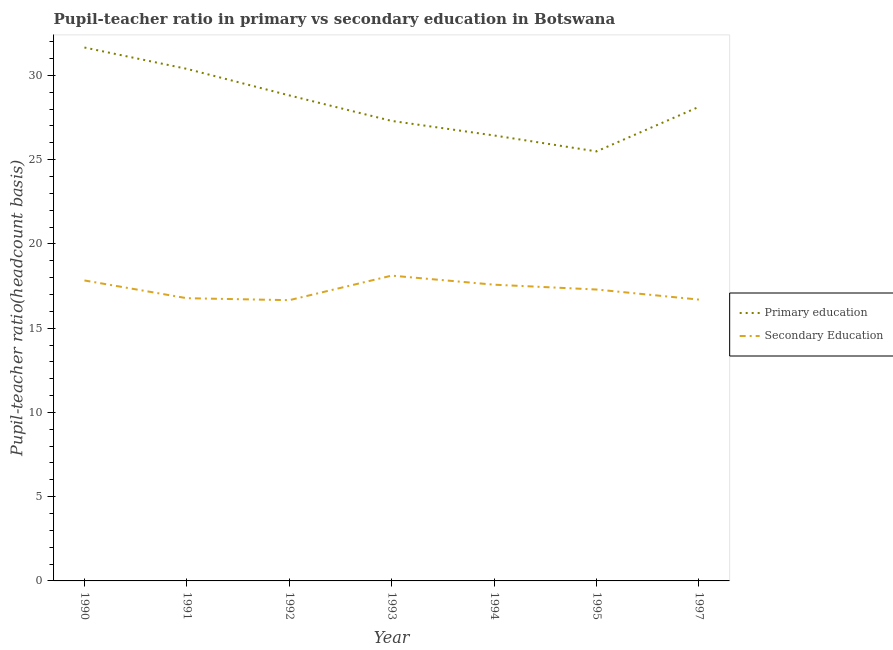Does the line corresponding to pupil-teacher ratio in primary education intersect with the line corresponding to pupil teacher ratio on secondary education?
Provide a short and direct response. No. What is the pupil teacher ratio on secondary education in 1995?
Provide a succinct answer. 17.29. Across all years, what is the maximum pupil-teacher ratio in primary education?
Make the answer very short. 31.66. Across all years, what is the minimum pupil-teacher ratio in primary education?
Your answer should be very brief. 25.49. In which year was the pupil-teacher ratio in primary education maximum?
Provide a short and direct response. 1990. In which year was the pupil teacher ratio on secondary education minimum?
Offer a terse response. 1992. What is the total pupil-teacher ratio in primary education in the graph?
Provide a succinct answer. 198.22. What is the difference between the pupil-teacher ratio in primary education in 1991 and that in 1993?
Give a very brief answer. 3.09. What is the difference between the pupil teacher ratio on secondary education in 1995 and the pupil-teacher ratio in primary education in 1993?
Provide a short and direct response. -10.01. What is the average pupil-teacher ratio in primary education per year?
Your answer should be very brief. 28.32. In the year 1995, what is the difference between the pupil teacher ratio on secondary education and pupil-teacher ratio in primary education?
Give a very brief answer. -8.2. In how many years, is the pupil-teacher ratio in primary education greater than 26?
Keep it short and to the point. 6. What is the ratio of the pupil teacher ratio on secondary education in 1992 to that in 1993?
Your answer should be very brief. 0.92. Is the pupil-teacher ratio in primary education in 1994 less than that in 1997?
Offer a very short reply. Yes. What is the difference between the highest and the second highest pupil teacher ratio on secondary education?
Your answer should be very brief. 0.29. What is the difference between the highest and the lowest pupil-teacher ratio in primary education?
Provide a succinct answer. 6.17. Is the sum of the pupil-teacher ratio in primary education in 1990 and 1995 greater than the maximum pupil teacher ratio on secondary education across all years?
Make the answer very short. Yes. How many lines are there?
Your answer should be very brief. 2. Does the graph contain any zero values?
Your answer should be compact. No. How many legend labels are there?
Your response must be concise. 2. How are the legend labels stacked?
Your response must be concise. Vertical. What is the title of the graph?
Your answer should be very brief. Pupil-teacher ratio in primary vs secondary education in Botswana. Does "Non-solid fuel" appear as one of the legend labels in the graph?
Give a very brief answer. No. What is the label or title of the X-axis?
Make the answer very short. Year. What is the label or title of the Y-axis?
Provide a short and direct response. Pupil-teacher ratio(headcount basis). What is the Pupil-teacher ratio(headcount basis) of Primary education in 1990?
Provide a succinct answer. 31.66. What is the Pupil-teacher ratio(headcount basis) in Secondary Education in 1990?
Provide a succinct answer. 17.83. What is the Pupil-teacher ratio(headcount basis) in Primary education in 1991?
Make the answer very short. 30.39. What is the Pupil-teacher ratio(headcount basis) of Secondary Education in 1991?
Your answer should be very brief. 16.78. What is the Pupil-teacher ratio(headcount basis) in Primary education in 1992?
Make the answer very short. 28.81. What is the Pupil-teacher ratio(headcount basis) in Secondary Education in 1992?
Give a very brief answer. 16.66. What is the Pupil-teacher ratio(headcount basis) in Primary education in 1993?
Your answer should be very brief. 27.3. What is the Pupil-teacher ratio(headcount basis) of Secondary Education in 1993?
Provide a short and direct response. 18.12. What is the Pupil-teacher ratio(headcount basis) in Primary education in 1994?
Ensure brevity in your answer.  26.44. What is the Pupil-teacher ratio(headcount basis) of Secondary Education in 1994?
Give a very brief answer. 17.58. What is the Pupil-teacher ratio(headcount basis) in Primary education in 1995?
Make the answer very short. 25.49. What is the Pupil-teacher ratio(headcount basis) in Secondary Education in 1995?
Your answer should be compact. 17.29. What is the Pupil-teacher ratio(headcount basis) in Primary education in 1997?
Offer a terse response. 28.14. What is the Pupil-teacher ratio(headcount basis) in Secondary Education in 1997?
Provide a short and direct response. 16.7. Across all years, what is the maximum Pupil-teacher ratio(headcount basis) in Primary education?
Your response must be concise. 31.66. Across all years, what is the maximum Pupil-teacher ratio(headcount basis) in Secondary Education?
Give a very brief answer. 18.12. Across all years, what is the minimum Pupil-teacher ratio(headcount basis) in Primary education?
Offer a terse response. 25.49. Across all years, what is the minimum Pupil-teacher ratio(headcount basis) of Secondary Education?
Give a very brief answer. 16.66. What is the total Pupil-teacher ratio(headcount basis) in Primary education in the graph?
Offer a terse response. 198.22. What is the total Pupil-teacher ratio(headcount basis) in Secondary Education in the graph?
Ensure brevity in your answer.  120.96. What is the difference between the Pupil-teacher ratio(headcount basis) in Primary education in 1990 and that in 1991?
Offer a terse response. 1.27. What is the difference between the Pupil-teacher ratio(headcount basis) in Secondary Education in 1990 and that in 1991?
Provide a succinct answer. 1.05. What is the difference between the Pupil-teacher ratio(headcount basis) of Primary education in 1990 and that in 1992?
Ensure brevity in your answer.  2.84. What is the difference between the Pupil-teacher ratio(headcount basis) of Secondary Education in 1990 and that in 1992?
Provide a succinct answer. 1.17. What is the difference between the Pupil-teacher ratio(headcount basis) in Primary education in 1990 and that in 1993?
Offer a very short reply. 4.36. What is the difference between the Pupil-teacher ratio(headcount basis) of Secondary Education in 1990 and that in 1993?
Offer a terse response. -0.29. What is the difference between the Pupil-teacher ratio(headcount basis) in Primary education in 1990 and that in 1994?
Make the answer very short. 5.22. What is the difference between the Pupil-teacher ratio(headcount basis) in Secondary Education in 1990 and that in 1994?
Ensure brevity in your answer.  0.25. What is the difference between the Pupil-teacher ratio(headcount basis) in Primary education in 1990 and that in 1995?
Ensure brevity in your answer.  6.17. What is the difference between the Pupil-teacher ratio(headcount basis) of Secondary Education in 1990 and that in 1995?
Ensure brevity in your answer.  0.54. What is the difference between the Pupil-teacher ratio(headcount basis) of Primary education in 1990 and that in 1997?
Give a very brief answer. 3.52. What is the difference between the Pupil-teacher ratio(headcount basis) in Secondary Education in 1990 and that in 1997?
Provide a short and direct response. 1.14. What is the difference between the Pupil-teacher ratio(headcount basis) of Primary education in 1991 and that in 1992?
Offer a terse response. 1.57. What is the difference between the Pupil-teacher ratio(headcount basis) of Secondary Education in 1991 and that in 1992?
Ensure brevity in your answer.  0.12. What is the difference between the Pupil-teacher ratio(headcount basis) of Primary education in 1991 and that in 1993?
Your response must be concise. 3.09. What is the difference between the Pupil-teacher ratio(headcount basis) of Secondary Education in 1991 and that in 1993?
Give a very brief answer. -1.34. What is the difference between the Pupil-teacher ratio(headcount basis) of Primary education in 1991 and that in 1994?
Ensure brevity in your answer.  3.95. What is the difference between the Pupil-teacher ratio(headcount basis) in Secondary Education in 1991 and that in 1994?
Give a very brief answer. -0.8. What is the difference between the Pupil-teacher ratio(headcount basis) of Primary education in 1991 and that in 1995?
Keep it short and to the point. 4.9. What is the difference between the Pupil-teacher ratio(headcount basis) of Secondary Education in 1991 and that in 1995?
Offer a very short reply. -0.52. What is the difference between the Pupil-teacher ratio(headcount basis) of Primary education in 1991 and that in 1997?
Your answer should be compact. 2.25. What is the difference between the Pupil-teacher ratio(headcount basis) of Secondary Education in 1991 and that in 1997?
Make the answer very short. 0.08. What is the difference between the Pupil-teacher ratio(headcount basis) of Primary education in 1992 and that in 1993?
Make the answer very short. 1.51. What is the difference between the Pupil-teacher ratio(headcount basis) in Secondary Education in 1992 and that in 1993?
Your answer should be compact. -1.46. What is the difference between the Pupil-teacher ratio(headcount basis) of Primary education in 1992 and that in 1994?
Your response must be concise. 2.38. What is the difference between the Pupil-teacher ratio(headcount basis) in Secondary Education in 1992 and that in 1994?
Keep it short and to the point. -0.92. What is the difference between the Pupil-teacher ratio(headcount basis) in Primary education in 1992 and that in 1995?
Your response must be concise. 3.32. What is the difference between the Pupil-teacher ratio(headcount basis) in Secondary Education in 1992 and that in 1995?
Offer a very short reply. -0.63. What is the difference between the Pupil-teacher ratio(headcount basis) of Primary education in 1992 and that in 1997?
Ensure brevity in your answer.  0.68. What is the difference between the Pupil-teacher ratio(headcount basis) in Secondary Education in 1992 and that in 1997?
Your answer should be very brief. -0.03. What is the difference between the Pupil-teacher ratio(headcount basis) of Primary education in 1993 and that in 1994?
Your answer should be very brief. 0.86. What is the difference between the Pupil-teacher ratio(headcount basis) in Secondary Education in 1993 and that in 1994?
Provide a succinct answer. 0.54. What is the difference between the Pupil-teacher ratio(headcount basis) of Primary education in 1993 and that in 1995?
Your response must be concise. 1.81. What is the difference between the Pupil-teacher ratio(headcount basis) of Secondary Education in 1993 and that in 1995?
Give a very brief answer. 0.82. What is the difference between the Pupil-teacher ratio(headcount basis) of Primary education in 1993 and that in 1997?
Your answer should be compact. -0.84. What is the difference between the Pupil-teacher ratio(headcount basis) of Secondary Education in 1993 and that in 1997?
Keep it short and to the point. 1.42. What is the difference between the Pupil-teacher ratio(headcount basis) in Primary education in 1994 and that in 1995?
Offer a very short reply. 0.95. What is the difference between the Pupil-teacher ratio(headcount basis) in Secondary Education in 1994 and that in 1995?
Keep it short and to the point. 0.29. What is the difference between the Pupil-teacher ratio(headcount basis) in Primary education in 1994 and that in 1997?
Provide a succinct answer. -1.7. What is the difference between the Pupil-teacher ratio(headcount basis) in Secondary Education in 1994 and that in 1997?
Your response must be concise. 0.88. What is the difference between the Pupil-teacher ratio(headcount basis) in Primary education in 1995 and that in 1997?
Give a very brief answer. -2.64. What is the difference between the Pupil-teacher ratio(headcount basis) of Secondary Education in 1995 and that in 1997?
Ensure brevity in your answer.  0.6. What is the difference between the Pupil-teacher ratio(headcount basis) of Primary education in 1990 and the Pupil-teacher ratio(headcount basis) of Secondary Education in 1991?
Keep it short and to the point. 14.88. What is the difference between the Pupil-teacher ratio(headcount basis) in Primary education in 1990 and the Pupil-teacher ratio(headcount basis) in Secondary Education in 1992?
Make the answer very short. 14.99. What is the difference between the Pupil-teacher ratio(headcount basis) of Primary education in 1990 and the Pupil-teacher ratio(headcount basis) of Secondary Education in 1993?
Make the answer very short. 13.54. What is the difference between the Pupil-teacher ratio(headcount basis) in Primary education in 1990 and the Pupil-teacher ratio(headcount basis) in Secondary Education in 1994?
Your answer should be very brief. 14.08. What is the difference between the Pupil-teacher ratio(headcount basis) of Primary education in 1990 and the Pupil-teacher ratio(headcount basis) of Secondary Education in 1995?
Offer a terse response. 14.36. What is the difference between the Pupil-teacher ratio(headcount basis) of Primary education in 1990 and the Pupil-teacher ratio(headcount basis) of Secondary Education in 1997?
Ensure brevity in your answer.  14.96. What is the difference between the Pupil-teacher ratio(headcount basis) in Primary education in 1991 and the Pupil-teacher ratio(headcount basis) in Secondary Education in 1992?
Provide a short and direct response. 13.73. What is the difference between the Pupil-teacher ratio(headcount basis) of Primary education in 1991 and the Pupil-teacher ratio(headcount basis) of Secondary Education in 1993?
Offer a very short reply. 12.27. What is the difference between the Pupil-teacher ratio(headcount basis) of Primary education in 1991 and the Pupil-teacher ratio(headcount basis) of Secondary Education in 1994?
Provide a succinct answer. 12.81. What is the difference between the Pupil-teacher ratio(headcount basis) of Primary education in 1991 and the Pupil-teacher ratio(headcount basis) of Secondary Education in 1995?
Ensure brevity in your answer.  13.1. What is the difference between the Pupil-teacher ratio(headcount basis) of Primary education in 1991 and the Pupil-teacher ratio(headcount basis) of Secondary Education in 1997?
Make the answer very short. 13.69. What is the difference between the Pupil-teacher ratio(headcount basis) in Primary education in 1992 and the Pupil-teacher ratio(headcount basis) in Secondary Education in 1993?
Ensure brevity in your answer.  10.7. What is the difference between the Pupil-teacher ratio(headcount basis) of Primary education in 1992 and the Pupil-teacher ratio(headcount basis) of Secondary Education in 1994?
Your answer should be very brief. 11.23. What is the difference between the Pupil-teacher ratio(headcount basis) in Primary education in 1992 and the Pupil-teacher ratio(headcount basis) in Secondary Education in 1995?
Ensure brevity in your answer.  11.52. What is the difference between the Pupil-teacher ratio(headcount basis) of Primary education in 1992 and the Pupil-teacher ratio(headcount basis) of Secondary Education in 1997?
Your answer should be compact. 12.12. What is the difference between the Pupil-teacher ratio(headcount basis) of Primary education in 1993 and the Pupil-teacher ratio(headcount basis) of Secondary Education in 1994?
Offer a terse response. 9.72. What is the difference between the Pupil-teacher ratio(headcount basis) of Primary education in 1993 and the Pupil-teacher ratio(headcount basis) of Secondary Education in 1995?
Your answer should be compact. 10.01. What is the difference between the Pupil-teacher ratio(headcount basis) of Primary education in 1993 and the Pupil-teacher ratio(headcount basis) of Secondary Education in 1997?
Offer a terse response. 10.6. What is the difference between the Pupil-teacher ratio(headcount basis) in Primary education in 1994 and the Pupil-teacher ratio(headcount basis) in Secondary Education in 1995?
Your answer should be compact. 9.14. What is the difference between the Pupil-teacher ratio(headcount basis) of Primary education in 1994 and the Pupil-teacher ratio(headcount basis) of Secondary Education in 1997?
Give a very brief answer. 9.74. What is the difference between the Pupil-teacher ratio(headcount basis) of Primary education in 1995 and the Pupil-teacher ratio(headcount basis) of Secondary Education in 1997?
Make the answer very short. 8.79. What is the average Pupil-teacher ratio(headcount basis) in Primary education per year?
Ensure brevity in your answer.  28.32. What is the average Pupil-teacher ratio(headcount basis) of Secondary Education per year?
Provide a succinct answer. 17.28. In the year 1990, what is the difference between the Pupil-teacher ratio(headcount basis) of Primary education and Pupil-teacher ratio(headcount basis) of Secondary Education?
Keep it short and to the point. 13.82. In the year 1991, what is the difference between the Pupil-teacher ratio(headcount basis) of Primary education and Pupil-teacher ratio(headcount basis) of Secondary Education?
Provide a succinct answer. 13.61. In the year 1992, what is the difference between the Pupil-teacher ratio(headcount basis) of Primary education and Pupil-teacher ratio(headcount basis) of Secondary Education?
Your answer should be compact. 12.15. In the year 1993, what is the difference between the Pupil-teacher ratio(headcount basis) in Primary education and Pupil-teacher ratio(headcount basis) in Secondary Education?
Make the answer very short. 9.18. In the year 1994, what is the difference between the Pupil-teacher ratio(headcount basis) of Primary education and Pupil-teacher ratio(headcount basis) of Secondary Education?
Give a very brief answer. 8.86. In the year 1995, what is the difference between the Pupil-teacher ratio(headcount basis) of Primary education and Pupil-teacher ratio(headcount basis) of Secondary Education?
Offer a very short reply. 8.2. In the year 1997, what is the difference between the Pupil-teacher ratio(headcount basis) in Primary education and Pupil-teacher ratio(headcount basis) in Secondary Education?
Make the answer very short. 11.44. What is the ratio of the Pupil-teacher ratio(headcount basis) of Primary education in 1990 to that in 1991?
Keep it short and to the point. 1.04. What is the ratio of the Pupil-teacher ratio(headcount basis) in Secondary Education in 1990 to that in 1991?
Provide a succinct answer. 1.06. What is the ratio of the Pupil-teacher ratio(headcount basis) in Primary education in 1990 to that in 1992?
Your answer should be compact. 1.1. What is the ratio of the Pupil-teacher ratio(headcount basis) of Secondary Education in 1990 to that in 1992?
Your answer should be very brief. 1.07. What is the ratio of the Pupil-teacher ratio(headcount basis) in Primary education in 1990 to that in 1993?
Provide a short and direct response. 1.16. What is the ratio of the Pupil-teacher ratio(headcount basis) of Secondary Education in 1990 to that in 1993?
Your answer should be very brief. 0.98. What is the ratio of the Pupil-teacher ratio(headcount basis) of Primary education in 1990 to that in 1994?
Keep it short and to the point. 1.2. What is the ratio of the Pupil-teacher ratio(headcount basis) in Secondary Education in 1990 to that in 1994?
Provide a short and direct response. 1.01. What is the ratio of the Pupil-teacher ratio(headcount basis) in Primary education in 1990 to that in 1995?
Provide a succinct answer. 1.24. What is the ratio of the Pupil-teacher ratio(headcount basis) in Secondary Education in 1990 to that in 1995?
Give a very brief answer. 1.03. What is the ratio of the Pupil-teacher ratio(headcount basis) in Primary education in 1990 to that in 1997?
Your answer should be very brief. 1.13. What is the ratio of the Pupil-teacher ratio(headcount basis) of Secondary Education in 1990 to that in 1997?
Provide a short and direct response. 1.07. What is the ratio of the Pupil-teacher ratio(headcount basis) in Primary education in 1991 to that in 1992?
Your answer should be compact. 1.05. What is the ratio of the Pupil-teacher ratio(headcount basis) in Secondary Education in 1991 to that in 1992?
Provide a succinct answer. 1.01. What is the ratio of the Pupil-teacher ratio(headcount basis) in Primary education in 1991 to that in 1993?
Your answer should be compact. 1.11. What is the ratio of the Pupil-teacher ratio(headcount basis) of Secondary Education in 1991 to that in 1993?
Keep it short and to the point. 0.93. What is the ratio of the Pupil-teacher ratio(headcount basis) of Primary education in 1991 to that in 1994?
Offer a terse response. 1.15. What is the ratio of the Pupil-teacher ratio(headcount basis) in Secondary Education in 1991 to that in 1994?
Your answer should be very brief. 0.95. What is the ratio of the Pupil-teacher ratio(headcount basis) of Primary education in 1991 to that in 1995?
Give a very brief answer. 1.19. What is the ratio of the Pupil-teacher ratio(headcount basis) in Secondary Education in 1991 to that in 1995?
Ensure brevity in your answer.  0.97. What is the ratio of the Pupil-teacher ratio(headcount basis) of Primary education in 1991 to that in 1997?
Offer a terse response. 1.08. What is the ratio of the Pupil-teacher ratio(headcount basis) in Secondary Education in 1991 to that in 1997?
Offer a terse response. 1. What is the ratio of the Pupil-teacher ratio(headcount basis) in Primary education in 1992 to that in 1993?
Provide a short and direct response. 1.06. What is the ratio of the Pupil-teacher ratio(headcount basis) of Secondary Education in 1992 to that in 1993?
Provide a succinct answer. 0.92. What is the ratio of the Pupil-teacher ratio(headcount basis) in Primary education in 1992 to that in 1994?
Offer a very short reply. 1.09. What is the ratio of the Pupil-teacher ratio(headcount basis) in Secondary Education in 1992 to that in 1994?
Your answer should be compact. 0.95. What is the ratio of the Pupil-teacher ratio(headcount basis) in Primary education in 1992 to that in 1995?
Your answer should be very brief. 1.13. What is the ratio of the Pupil-teacher ratio(headcount basis) of Secondary Education in 1992 to that in 1995?
Provide a short and direct response. 0.96. What is the ratio of the Pupil-teacher ratio(headcount basis) in Primary education in 1992 to that in 1997?
Provide a short and direct response. 1.02. What is the ratio of the Pupil-teacher ratio(headcount basis) of Primary education in 1993 to that in 1994?
Make the answer very short. 1.03. What is the ratio of the Pupil-teacher ratio(headcount basis) in Secondary Education in 1993 to that in 1994?
Keep it short and to the point. 1.03. What is the ratio of the Pupil-teacher ratio(headcount basis) of Primary education in 1993 to that in 1995?
Make the answer very short. 1.07. What is the ratio of the Pupil-teacher ratio(headcount basis) in Secondary Education in 1993 to that in 1995?
Give a very brief answer. 1.05. What is the ratio of the Pupil-teacher ratio(headcount basis) in Primary education in 1993 to that in 1997?
Offer a terse response. 0.97. What is the ratio of the Pupil-teacher ratio(headcount basis) of Secondary Education in 1993 to that in 1997?
Offer a terse response. 1.09. What is the ratio of the Pupil-teacher ratio(headcount basis) in Primary education in 1994 to that in 1995?
Provide a succinct answer. 1.04. What is the ratio of the Pupil-teacher ratio(headcount basis) of Secondary Education in 1994 to that in 1995?
Give a very brief answer. 1.02. What is the ratio of the Pupil-teacher ratio(headcount basis) in Primary education in 1994 to that in 1997?
Offer a terse response. 0.94. What is the ratio of the Pupil-teacher ratio(headcount basis) in Secondary Education in 1994 to that in 1997?
Ensure brevity in your answer.  1.05. What is the ratio of the Pupil-teacher ratio(headcount basis) in Primary education in 1995 to that in 1997?
Make the answer very short. 0.91. What is the ratio of the Pupil-teacher ratio(headcount basis) in Secondary Education in 1995 to that in 1997?
Ensure brevity in your answer.  1.04. What is the difference between the highest and the second highest Pupil-teacher ratio(headcount basis) of Primary education?
Make the answer very short. 1.27. What is the difference between the highest and the second highest Pupil-teacher ratio(headcount basis) in Secondary Education?
Keep it short and to the point. 0.29. What is the difference between the highest and the lowest Pupil-teacher ratio(headcount basis) in Primary education?
Provide a succinct answer. 6.17. What is the difference between the highest and the lowest Pupil-teacher ratio(headcount basis) of Secondary Education?
Offer a terse response. 1.46. 